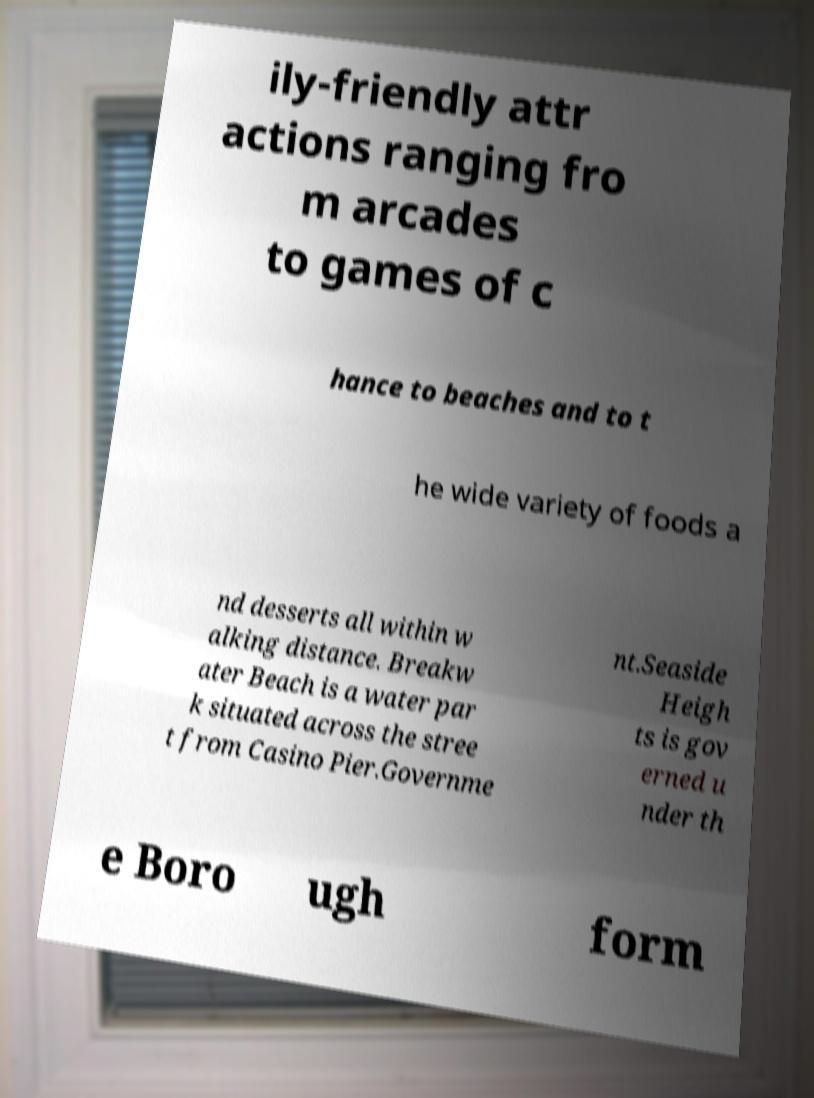Please identify and transcribe the text found in this image. ily-friendly attr actions ranging fro m arcades to games of c hance to beaches and to t he wide variety of foods a nd desserts all within w alking distance. Breakw ater Beach is a water par k situated across the stree t from Casino Pier.Governme nt.Seaside Heigh ts is gov erned u nder th e Boro ugh form 